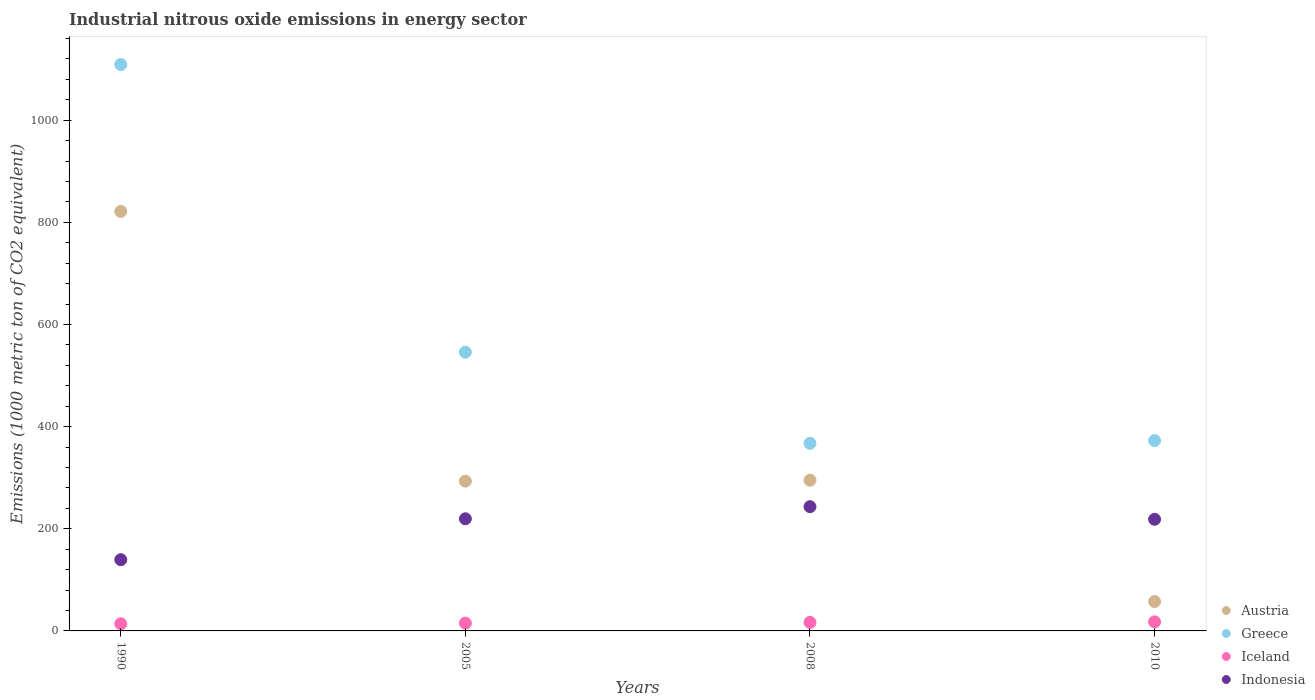How many different coloured dotlines are there?
Your response must be concise. 4. What is the amount of industrial nitrous oxide emitted in Austria in 2010?
Give a very brief answer. 57.5. Across all years, what is the maximum amount of industrial nitrous oxide emitted in Greece?
Ensure brevity in your answer.  1109.1. Across all years, what is the minimum amount of industrial nitrous oxide emitted in Indonesia?
Offer a terse response. 139.5. In which year was the amount of industrial nitrous oxide emitted in Austria minimum?
Provide a succinct answer. 2010. What is the total amount of industrial nitrous oxide emitted in Greece in the graph?
Your answer should be compact. 2395. What is the difference between the amount of industrial nitrous oxide emitted in Iceland in 1990 and that in 2008?
Your answer should be compact. -2.7. What is the difference between the amount of industrial nitrous oxide emitted in Iceland in 2008 and the amount of industrial nitrous oxide emitted in Indonesia in 2010?
Make the answer very short. -201.9. What is the average amount of industrial nitrous oxide emitted in Iceland per year?
Make the answer very short. 15.93. In the year 2008, what is the difference between the amount of industrial nitrous oxide emitted in Greece and amount of industrial nitrous oxide emitted in Indonesia?
Offer a terse response. 124.1. What is the ratio of the amount of industrial nitrous oxide emitted in Indonesia in 1990 to that in 2005?
Your response must be concise. 0.64. What is the difference between the highest and the second highest amount of industrial nitrous oxide emitted in Austria?
Provide a short and direct response. 526.3. What is the difference between the highest and the lowest amount of industrial nitrous oxide emitted in Austria?
Your answer should be very brief. 764. Is it the case that in every year, the sum of the amount of industrial nitrous oxide emitted in Greece and amount of industrial nitrous oxide emitted in Iceland  is greater than the sum of amount of industrial nitrous oxide emitted in Austria and amount of industrial nitrous oxide emitted in Indonesia?
Make the answer very short. Yes. Is the amount of industrial nitrous oxide emitted in Greece strictly greater than the amount of industrial nitrous oxide emitted in Austria over the years?
Ensure brevity in your answer.  Yes. Is the amount of industrial nitrous oxide emitted in Austria strictly less than the amount of industrial nitrous oxide emitted in Greece over the years?
Your response must be concise. Yes. What is the difference between two consecutive major ticks on the Y-axis?
Offer a very short reply. 200. Are the values on the major ticks of Y-axis written in scientific E-notation?
Keep it short and to the point. No. Does the graph contain grids?
Your answer should be compact. No. Where does the legend appear in the graph?
Provide a succinct answer. Bottom right. How many legend labels are there?
Your answer should be very brief. 4. How are the legend labels stacked?
Give a very brief answer. Vertical. What is the title of the graph?
Provide a succinct answer. Industrial nitrous oxide emissions in energy sector. What is the label or title of the Y-axis?
Keep it short and to the point. Emissions (1000 metric ton of CO2 equivalent). What is the Emissions (1000 metric ton of CO2 equivalent) in Austria in 1990?
Make the answer very short. 821.5. What is the Emissions (1000 metric ton of CO2 equivalent) of Greece in 1990?
Offer a terse response. 1109.1. What is the Emissions (1000 metric ton of CO2 equivalent) of Iceland in 1990?
Offer a terse response. 14. What is the Emissions (1000 metric ton of CO2 equivalent) in Indonesia in 1990?
Your answer should be compact. 139.5. What is the Emissions (1000 metric ton of CO2 equivalent) in Austria in 2005?
Make the answer very short. 293.3. What is the Emissions (1000 metric ton of CO2 equivalent) of Greece in 2005?
Your response must be concise. 545.8. What is the Emissions (1000 metric ton of CO2 equivalent) of Indonesia in 2005?
Give a very brief answer. 219.6. What is the Emissions (1000 metric ton of CO2 equivalent) of Austria in 2008?
Your response must be concise. 295.2. What is the Emissions (1000 metric ton of CO2 equivalent) of Greece in 2008?
Make the answer very short. 367.4. What is the Emissions (1000 metric ton of CO2 equivalent) in Indonesia in 2008?
Provide a short and direct response. 243.3. What is the Emissions (1000 metric ton of CO2 equivalent) in Austria in 2010?
Offer a very short reply. 57.5. What is the Emissions (1000 metric ton of CO2 equivalent) of Greece in 2010?
Offer a very short reply. 372.7. What is the Emissions (1000 metric ton of CO2 equivalent) of Indonesia in 2010?
Your response must be concise. 218.6. Across all years, what is the maximum Emissions (1000 metric ton of CO2 equivalent) in Austria?
Your response must be concise. 821.5. Across all years, what is the maximum Emissions (1000 metric ton of CO2 equivalent) of Greece?
Offer a very short reply. 1109.1. Across all years, what is the maximum Emissions (1000 metric ton of CO2 equivalent) of Iceland?
Ensure brevity in your answer.  17.7. Across all years, what is the maximum Emissions (1000 metric ton of CO2 equivalent) in Indonesia?
Give a very brief answer. 243.3. Across all years, what is the minimum Emissions (1000 metric ton of CO2 equivalent) in Austria?
Make the answer very short. 57.5. Across all years, what is the minimum Emissions (1000 metric ton of CO2 equivalent) in Greece?
Keep it short and to the point. 367.4. Across all years, what is the minimum Emissions (1000 metric ton of CO2 equivalent) of Indonesia?
Offer a terse response. 139.5. What is the total Emissions (1000 metric ton of CO2 equivalent) in Austria in the graph?
Ensure brevity in your answer.  1467.5. What is the total Emissions (1000 metric ton of CO2 equivalent) in Greece in the graph?
Offer a terse response. 2395. What is the total Emissions (1000 metric ton of CO2 equivalent) in Iceland in the graph?
Keep it short and to the point. 63.7. What is the total Emissions (1000 metric ton of CO2 equivalent) in Indonesia in the graph?
Provide a succinct answer. 821. What is the difference between the Emissions (1000 metric ton of CO2 equivalent) in Austria in 1990 and that in 2005?
Offer a terse response. 528.2. What is the difference between the Emissions (1000 metric ton of CO2 equivalent) of Greece in 1990 and that in 2005?
Your answer should be compact. 563.3. What is the difference between the Emissions (1000 metric ton of CO2 equivalent) in Indonesia in 1990 and that in 2005?
Offer a terse response. -80.1. What is the difference between the Emissions (1000 metric ton of CO2 equivalent) of Austria in 1990 and that in 2008?
Offer a terse response. 526.3. What is the difference between the Emissions (1000 metric ton of CO2 equivalent) of Greece in 1990 and that in 2008?
Offer a very short reply. 741.7. What is the difference between the Emissions (1000 metric ton of CO2 equivalent) of Indonesia in 1990 and that in 2008?
Keep it short and to the point. -103.8. What is the difference between the Emissions (1000 metric ton of CO2 equivalent) of Austria in 1990 and that in 2010?
Make the answer very short. 764. What is the difference between the Emissions (1000 metric ton of CO2 equivalent) of Greece in 1990 and that in 2010?
Provide a short and direct response. 736.4. What is the difference between the Emissions (1000 metric ton of CO2 equivalent) in Iceland in 1990 and that in 2010?
Keep it short and to the point. -3.7. What is the difference between the Emissions (1000 metric ton of CO2 equivalent) in Indonesia in 1990 and that in 2010?
Your answer should be very brief. -79.1. What is the difference between the Emissions (1000 metric ton of CO2 equivalent) in Austria in 2005 and that in 2008?
Offer a very short reply. -1.9. What is the difference between the Emissions (1000 metric ton of CO2 equivalent) in Greece in 2005 and that in 2008?
Give a very brief answer. 178.4. What is the difference between the Emissions (1000 metric ton of CO2 equivalent) in Indonesia in 2005 and that in 2008?
Offer a terse response. -23.7. What is the difference between the Emissions (1000 metric ton of CO2 equivalent) of Austria in 2005 and that in 2010?
Your answer should be very brief. 235.8. What is the difference between the Emissions (1000 metric ton of CO2 equivalent) in Greece in 2005 and that in 2010?
Offer a very short reply. 173.1. What is the difference between the Emissions (1000 metric ton of CO2 equivalent) in Austria in 2008 and that in 2010?
Keep it short and to the point. 237.7. What is the difference between the Emissions (1000 metric ton of CO2 equivalent) in Iceland in 2008 and that in 2010?
Provide a short and direct response. -1. What is the difference between the Emissions (1000 metric ton of CO2 equivalent) in Indonesia in 2008 and that in 2010?
Your answer should be very brief. 24.7. What is the difference between the Emissions (1000 metric ton of CO2 equivalent) of Austria in 1990 and the Emissions (1000 metric ton of CO2 equivalent) of Greece in 2005?
Provide a short and direct response. 275.7. What is the difference between the Emissions (1000 metric ton of CO2 equivalent) in Austria in 1990 and the Emissions (1000 metric ton of CO2 equivalent) in Iceland in 2005?
Ensure brevity in your answer.  806.2. What is the difference between the Emissions (1000 metric ton of CO2 equivalent) of Austria in 1990 and the Emissions (1000 metric ton of CO2 equivalent) of Indonesia in 2005?
Provide a succinct answer. 601.9. What is the difference between the Emissions (1000 metric ton of CO2 equivalent) of Greece in 1990 and the Emissions (1000 metric ton of CO2 equivalent) of Iceland in 2005?
Make the answer very short. 1093.8. What is the difference between the Emissions (1000 metric ton of CO2 equivalent) of Greece in 1990 and the Emissions (1000 metric ton of CO2 equivalent) of Indonesia in 2005?
Give a very brief answer. 889.5. What is the difference between the Emissions (1000 metric ton of CO2 equivalent) in Iceland in 1990 and the Emissions (1000 metric ton of CO2 equivalent) in Indonesia in 2005?
Your answer should be compact. -205.6. What is the difference between the Emissions (1000 metric ton of CO2 equivalent) in Austria in 1990 and the Emissions (1000 metric ton of CO2 equivalent) in Greece in 2008?
Your answer should be very brief. 454.1. What is the difference between the Emissions (1000 metric ton of CO2 equivalent) in Austria in 1990 and the Emissions (1000 metric ton of CO2 equivalent) in Iceland in 2008?
Give a very brief answer. 804.8. What is the difference between the Emissions (1000 metric ton of CO2 equivalent) in Austria in 1990 and the Emissions (1000 metric ton of CO2 equivalent) in Indonesia in 2008?
Ensure brevity in your answer.  578.2. What is the difference between the Emissions (1000 metric ton of CO2 equivalent) of Greece in 1990 and the Emissions (1000 metric ton of CO2 equivalent) of Iceland in 2008?
Offer a terse response. 1092.4. What is the difference between the Emissions (1000 metric ton of CO2 equivalent) of Greece in 1990 and the Emissions (1000 metric ton of CO2 equivalent) of Indonesia in 2008?
Provide a succinct answer. 865.8. What is the difference between the Emissions (1000 metric ton of CO2 equivalent) in Iceland in 1990 and the Emissions (1000 metric ton of CO2 equivalent) in Indonesia in 2008?
Give a very brief answer. -229.3. What is the difference between the Emissions (1000 metric ton of CO2 equivalent) of Austria in 1990 and the Emissions (1000 metric ton of CO2 equivalent) of Greece in 2010?
Offer a very short reply. 448.8. What is the difference between the Emissions (1000 metric ton of CO2 equivalent) in Austria in 1990 and the Emissions (1000 metric ton of CO2 equivalent) in Iceland in 2010?
Offer a very short reply. 803.8. What is the difference between the Emissions (1000 metric ton of CO2 equivalent) of Austria in 1990 and the Emissions (1000 metric ton of CO2 equivalent) of Indonesia in 2010?
Keep it short and to the point. 602.9. What is the difference between the Emissions (1000 metric ton of CO2 equivalent) in Greece in 1990 and the Emissions (1000 metric ton of CO2 equivalent) in Iceland in 2010?
Your answer should be very brief. 1091.4. What is the difference between the Emissions (1000 metric ton of CO2 equivalent) in Greece in 1990 and the Emissions (1000 metric ton of CO2 equivalent) in Indonesia in 2010?
Provide a short and direct response. 890.5. What is the difference between the Emissions (1000 metric ton of CO2 equivalent) of Iceland in 1990 and the Emissions (1000 metric ton of CO2 equivalent) of Indonesia in 2010?
Your response must be concise. -204.6. What is the difference between the Emissions (1000 metric ton of CO2 equivalent) in Austria in 2005 and the Emissions (1000 metric ton of CO2 equivalent) in Greece in 2008?
Your response must be concise. -74.1. What is the difference between the Emissions (1000 metric ton of CO2 equivalent) in Austria in 2005 and the Emissions (1000 metric ton of CO2 equivalent) in Iceland in 2008?
Offer a terse response. 276.6. What is the difference between the Emissions (1000 metric ton of CO2 equivalent) of Greece in 2005 and the Emissions (1000 metric ton of CO2 equivalent) of Iceland in 2008?
Provide a succinct answer. 529.1. What is the difference between the Emissions (1000 metric ton of CO2 equivalent) of Greece in 2005 and the Emissions (1000 metric ton of CO2 equivalent) of Indonesia in 2008?
Make the answer very short. 302.5. What is the difference between the Emissions (1000 metric ton of CO2 equivalent) in Iceland in 2005 and the Emissions (1000 metric ton of CO2 equivalent) in Indonesia in 2008?
Give a very brief answer. -228. What is the difference between the Emissions (1000 metric ton of CO2 equivalent) in Austria in 2005 and the Emissions (1000 metric ton of CO2 equivalent) in Greece in 2010?
Provide a succinct answer. -79.4. What is the difference between the Emissions (1000 metric ton of CO2 equivalent) in Austria in 2005 and the Emissions (1000 metric ton of CO2 equivalent) in Iceland in 2010?
Your answer should be very brief. 275.6. What is the difference between the Emissions (1000 metric ton of CO2 equivalent) of Austria in 2005 and the Emissions (1000 metric ton of CO2 equivalent) of Indonesia in 2010?
Provide a succinct answer. 74.7. What is the difference between the Emissions (1000 metric ton of CO2 equivalent) of Greece in 2005 and the Emissions (1000 metric ton of CO2 equivalent) of Iceland in 2010?
Your answer should be very brief. 528.1. What is the difference between the Emissions (1000 metric ton of CO2 equivalent) of Greece in 2005 and the Emissions (1000 metric ton of CO2 equivalent) of Indonesia in 2010?
Keep it short and to the point. 327.2. What is the difference between the Emissions (1000 metric ton of CO2 equivalent) in Iceland in 2005 and the Emissions (1000 metric ton of CO2 equivalent) in Indonesia in 2010?
Keep it short and to the point. -203.3. What is the difference between the Emissions (1000 metric ton of CO2 equivalent) of Austria in 2008 and the Emissions (1000 metric ton of CO2 equivalent) of Greece in 2010?
Offer a terse response. -77.5. What is the difference between the Emissions (1000 metric ton of CO2 equivalent) of Austria in 2008 and the Emissions (1000 metric ton of CO2 equivalent) of Iceland in 2010?
Your answer should be compact. 277.5. What is the difference between the Emissions (1000 metric ton of CO2 equivalent) of Austria in 2008 and the Emissions (1000 metric ton of CO2 equivalent) of Indonesia in 2010?
Ensure brevity in your answer.  76.6. What is the difference between the Emissions (1000 metric ton of CO2 equivalent) of Greece in 2008 and the Emissions (1000 metric ton of CO2 equivalent) of Iceland in 2010?
Ensure brevity in your answer.  349.7. What is the difference between the Emissions (1000 metric ton of CO2 equivalent) in Greece in 2008 and the Emissions (1000 metric ton of CO2 equivalent) in Indonesia in 2010?
Provide a succinct answer. 148.8. What is the difference between the Emissions (1000 metric ton of CO2 equivalent) in Iceland in 2008 and the Emissions (1000 metric ton of CO2 equivalent) in Indonesia in 2010?
Your answer should be compact. -201.9. What is the average Emissions (1000 metric ton of CO2 equivalent) of Austria per year?
Ensure brevity in your answer.  366.88. What is the average Emissions (1000 metric ton of CO2 equivalent) in Greece per year?
Provide a short and direct response. 598.75. What is the average Emissions (1000 metric ton of CO2 equivalent) of Iceland per year?
Your answer should be compact. 15.93. What is the average Emissions (1000 metric ton of CO2 equivalent) in Indonesia per year?
Offer a terse response. 205.25. In the year 1990, what is the difference between the Emissions (1000 metric ton of CO2 equivalent) in Austria and Emissions (1000 metric ton of CO2 equivalent) in Greece?
Your answer should be compact. -287.6. In the year 1990, what is the difference between the Emissions (1000 metric ton of CO2 equivalent) of Austria and Emissions (1000 metric ton of CO2 equivalent) of Iceland?
Your response must be concise. 807.5. In the year 1990, what is the difference between the Emissions (1000 metric ton of CO2 equivalent) in Austria and Emissions (1000 metric ton of CO2 equivalent) in Indonesia?
Your response must be concise. 682. In the year 1990, what is the difference between the Emissions (1000 metric ton of CO2 equivalent) in Greece and Emissions (1000 metric ton of CO2 equivalent) in Iceland?
Make the answer very short. 1095.1. In the year 1990, what is the difference between the Emissions (1000 metric ton of CO2 equivalent) of Greece and Emissions (1000 metric ton of CO2 equivalent) of Indonesia?
Offer a very short reply. 969.6. In the year 1990, what is the difference between the Emissions (1000 metric ton of CO2 equivalent) of Iceland and Emissions (1000 metric ton of CO2 equivalent) of Indonesia?
Give a very brief answer. -125.5. In the year 2005, what is the difference between the Emissions (1000 metric ton of CO2 equivalent) in Austria and Emissions (1000 metric ton of CO2 equivalent) in Greece?
Your answer should be compact. -252.5. In the year 2005, what is the difference between the Emissions (1000 metric ton of CO2 equivalent) in Austria and Emissions (1000 metric ton of CO2 equivalent) in Iceland?
Ensure brevity in your answer.  278. In the year 2005, what is the difference between the Emissions (1000 metric ton of CO2 equivalent) in Austria and Emissions (1000 metric ton of CO2 equivalent) in Indonesia?
Ensure brevity in your answer.  73.7. In the year 2005, what is the difference between the Emissions (1000 metric ton of CO2 equivalent) in Greece and Emissions (1000 metric ton of CO2 equivalent) in Iceland?
Your answer should be very brief. 530.5. In the year 2005, what is the difference between the Emissions (1000 metric ton of CO2 equivalent) of Greece and Emissions (1000 metric ton of CO2 equivalent) of Indonesia?
Keep it short and to the point. 326.2. In the year 2005, what is the difference between the Emissions (1000 metric ton of CO2 equivalent) in Iceland and Emissions (1000 metric ton of CO2 equivalent) in Indonesia?
Your answer should be compact. -204.3. In the year 2008, what is the difference between the Emissions (1000 metric ton of CO2 equivalent) of Austria and Emissions (1000 metric ton of CO2 equivalent) of Greece?
Ensure brevity in your answer.  -72.2. In the year 2008, what is the difference between the Emissions (1000 metric ton of CO2 equivalent) of Austria and Emissions (1000 metric ton of CO2 equivalent) of Iceland?
Offer a terse response. 278.5. In the year 2008, what is the difference between the Emissions (1000 metric ton of CO2 equivalent) of Austria and Emissions (1000 metric ton of CO2 equivalent) of Indonesia?
Your answer should be very brief. 51.9. In the year 2008, what is the difference between the Emissions (1000 metric ton of CO2 equivalent) of Greece and Emissions (1000 metric ton of CO2 equivalent) of Iceland?
Your answer should be very brief. 350.7. In the year 2008, what is the difference between the Emissions (1000 metric ton of CO2 equivalent) of Greece and Emissions (1000 metric ton of CO2 equivalent) of Indonesia?
Offer a very short reply. 124.1. In the year 2008, what is the difference between the Emissions (1000 metric ton of CO2 equivalent) in Iceland and Emissions (1000 metric ton of CO2 equivalent) in Indonesia?
Offer a very short reply. -226.6. In the year 2010, what is the difference between the Emissions (1000 metric ton of CO2 equivalent) in Austria and Emissions (1000 metric ton of CO2 equivalent) in Greece?
Your answer should be compact. -315.2. In the year 2010, what is the difference between the Emissions (1000 metric ton of CO2 equivalent) of Austria and Emissions (1000 metric ton of CO2 equivalent) of Iceland?
Make the answer very short. 39.8. In the year 2010, what is the difference between the Emissions (1000 metric ton of CO2 equivalent) of Austria and Emissions (1000 metric ton of CO2 equivalent) of Indonesia?
Give a very brief answer. -161.1. In the year 2010, what is the difference between the Emissions (1000 metric ton of CO2 equivalent) in Greece and Emissions (1000 metric ton of CO2 equivalent) in Iceland?
Your response must be concise. 355. In the year 2010, what is the difference between the Emissions (1000 metric ton of CO2 equivalent) of Greece and Emissions (1000 metric ton of CO2 equivalent) of Indonesia?
Offer a terse response. 154.1. In the year 2010, what is the difference between the Emissions (1000 metric ton of CO2 equivalent) of Iceland and Emissions (1000 metric ton of CO2 equivalent) of Indonesia?
Keep it short and to the point. -200.9. What is the ratio of the Emissions (1000 metric ton of CO2 equivalent) of Austria in 1990 to that in 2005?
Provide a succinct answer. 2.8. What is the ratio of the Emissions (1000 metric ton of CO2 equivalent) in Greece in 1990 to that in 2005?
Give a very brief answer. 2.03. What is the ratio of the Emissions (1000 metric ton of CO2 equivalent) in Iceland in 1990 to that in 2005?
Provide a short and direct response. 0.92. What is the ratio of the Emissions (1000 metric ton of CO2 equivalent) of Indonesia in 1990 to that in 2005?
Make the answer very short. 0.64. What is the ratio of the Emissions (1000 metric ton of CO2 equivalent) in Austria in 1990 to that in 2008?
Give a very brief answer. 2.78. What is the ratio of the Emissions (1000 metric ton of CO2 equivalent) of Greece in 1990 to that in 2008?
Give a very brief answer. 3.02. What is the ratio of the Emissions (1000 metric ton of CO2 equivalent) of Iceland in 1990 to that in 2008?
Keep it short and to the point. 0.84. What is the ratio of the Emissions (1000 metric ton of CO2 equivalent) of Indonesia in 1990 to that in 2008?
Keep it short and to the point. 0.57. What is the ratio of the Emissions (1000 metric ton of CO2 equivalent) of Austria in 1990 to that in 2010?
Offer a terse response. 14.29. What is the ratio of the Emissions (1000 metric ton of CO2 equivalent) of Greece in 1990 to that in 2010?
Your response must be concise. 2.98. What is the ratio of the Emissions (1000 metric ton of CO2 equivalent) of Iceland in 1990 to that in 2010?
Make the answer very short. 0.79. What is the ratio of the Emissions (1000 metric ton of CO2 equivalent) of Indonesia in 1990 to that in 2010?
Your response must be concise. 0.64. What is the ratio of the Emissions (1000 metric ton of CO2 equivalent) of Austria in 2005 to that in 2008?
Keep it short and to the point. 0.99. What is the ratio of the Emissions (1000 metric ton of CO2 equivalent) of Greece in 2005 to that in 2008?
Provide a short and direct response. 1.49. What is the ratio of the Emissions (1000 metric ton of CO2 equivalent) of Iceland in 2005 to that in 2008?
Make the answer very short. 0.92. What is the ratio of the Emissions (1000 metric ton of CO2 equivalent) of Indonesia in 2005 to that in 2008?
Offer a terse response. 0.9. What is the ratio of the Emissions (1000 metric ton of CO2 equivalent) of Austria in 2005 to that in 2010?
Your answer should be very brief. 5.1. What is the ratio of the Emissions (1000 metric ton of CO2 equivalent) in Greece in 2005 to that in 2010?
Make the answer very short. 1.46. What is the ratio of the Emissions (1000 metric ton of CO2 equivalent) in Iceland in 2005 to that in 2010?
Keep it short and to the point. 0.86. What is the ratio of the Emissions (1000 metric ton of CO2 equivalent) of Indonesia in 2005 to that in 2010?
Offer a very short reply. 1. What is the ratio of the Emissions (1000 metric ton of CO2 equivalent) in Austria in 2008 to that in 2010?
Your response must be concise. 5.13. What is the ratio of the Emissions (1000 metric ton of CO2 equivalent) of Greece in 2008 to that in 2010?
Offer a terse response. 0.99. What is the ratio of the Emissions (1000 metric ton of CO2 equivalent) of Iceland in 2008 to that in 2010?
Your answer should be compact. 0.94. What is the ratio of the Emissions (1000 metric ton of CO2 equivalent) in Indonesia in 2008 to that in 2010?
Give a very brief answer. 1.11. What is the difference between the highest and the second highest Emissions (1000 metric ton of CO2 equivalent) of Austria?
Offer a very short reply. 526.3. What is the difference between the highest and the second highest Emissions (1000 metric ton of CO2 equivalent) of Greece?
Offer a very short reply. 563.3. What is the difference between the highest and the second highest Emissions (1000 metric ton of CO2 equivalent) of Indonesia?
Keep it short and to the point. 23.7. What is the difference between the highest and the lowest Emissions (1000 metric ton of CO2 equivalent) in Austria?
Your answer should be compact. 764. What is the difference between the highest and the lowest Emissions (1000 metric ton of CO2 equivalent) of Greece?
Provide a succinct answer. 741.7. What is the difference between the highest and the lowest Emissions (1000 metric ton of CO2 equivalent) of Indonesia?
Offer a terse response. 103.8. 